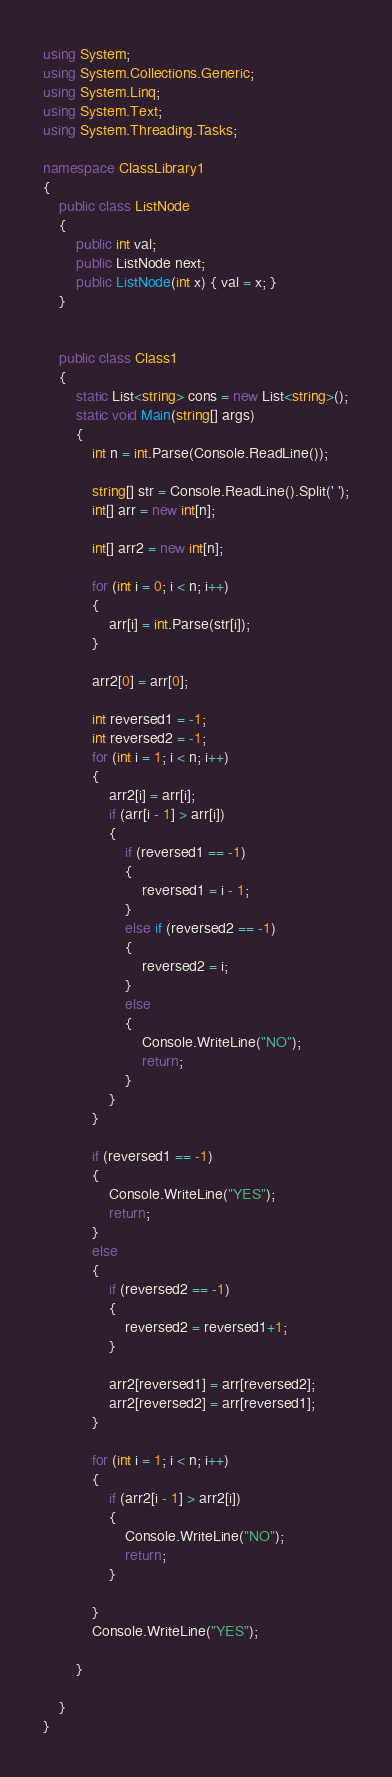<code> <loc_0><loc_0><loc_500><loc_500><_C#_>using System;
using System.Collections.Generic;
using System.Linq;
using System.Text;
using System.Threading.Tasks;

namespace ClassLibrary1
{
    public class ListNode
    {
        public int val;
        public ListNode next;
        public ListNode(int x) { val = x; }
    }


    public class Class1
    {
        static List<string> cons = new List<string>();
        static void Main(string[] args)
        {
            int n = int.Parse(Console.ReadLine());

            string[] str = Console.ReadLine().Split(' ');
            int[] arr = new int[n];

            int[] arr2 = new int[n];

            for (int i = 0; i < n; i++)
            {
                arr[i] = int.Parse(str[i]);
            }

            arr2[0] = arr[0];

            int reversed1 = -1;
            int reversed2 = -1;
            for (int i = 1; i < n; i++)
            {
                arr2[i] = arr[i];
                if (arr[i - 1] > arr[i])
                {
                    if (reversed1 == -1)
                    {
                        reversed1 = i - 1;
                    }
                    else if (reversed2 == -1)
                    {
                        reversed2 = i;
                    }
                    else
                    {
                        Console.WriteLine("NO");
                        return;
                    }
                }
            }

            if (reversed1 == -1)
            {
                Console.WriteLine("YES");
                return;
            }
            else
            {
                if (reversed2 == -1)
                {
                    reversed2 = reversed1+1;
                }

                arr2[reversed1] = arr[reversed2];
                arr2[reversed2] = arr[reversed1];
            }

            for (int i = 1; i < n; i++)
            {
                if (arr2[i - 1] > arr2[i])
                {
                    Console.WriteLine("NO");
                    return;
                }

            }
            Console.WriteLine("YES");

        }

    }
}</code> 